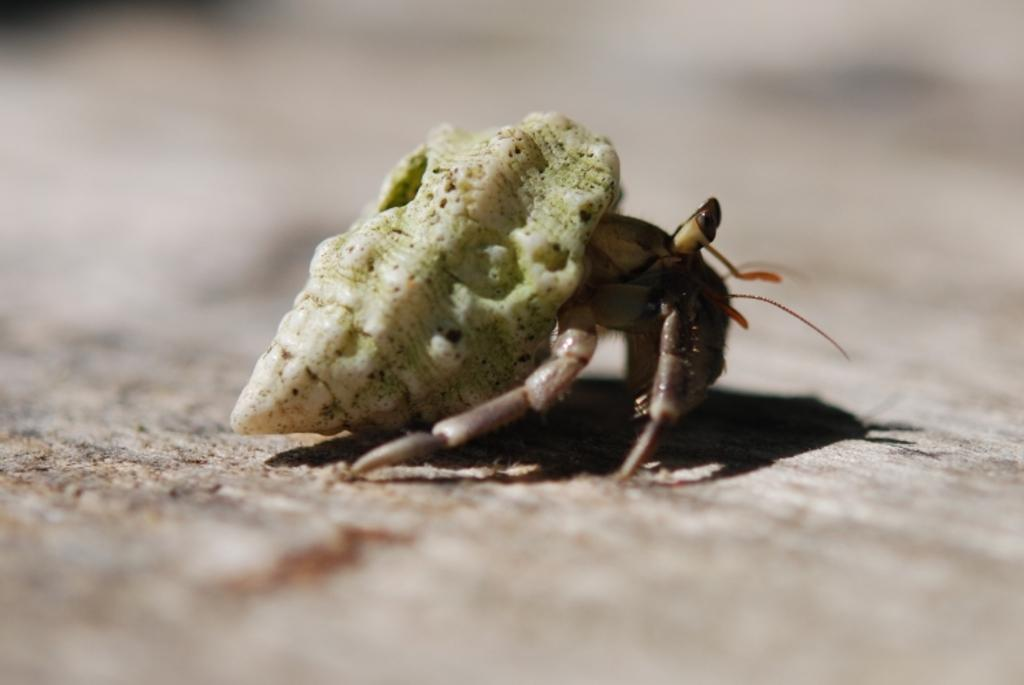What type of creature can be seen in the image? There is an insect in the image. Can you describe the background of the image? The background of the image is blurred. What type of mint is growing near the window in the image? There is no mint or window present in the image; it only features an insect and a blurred background. 